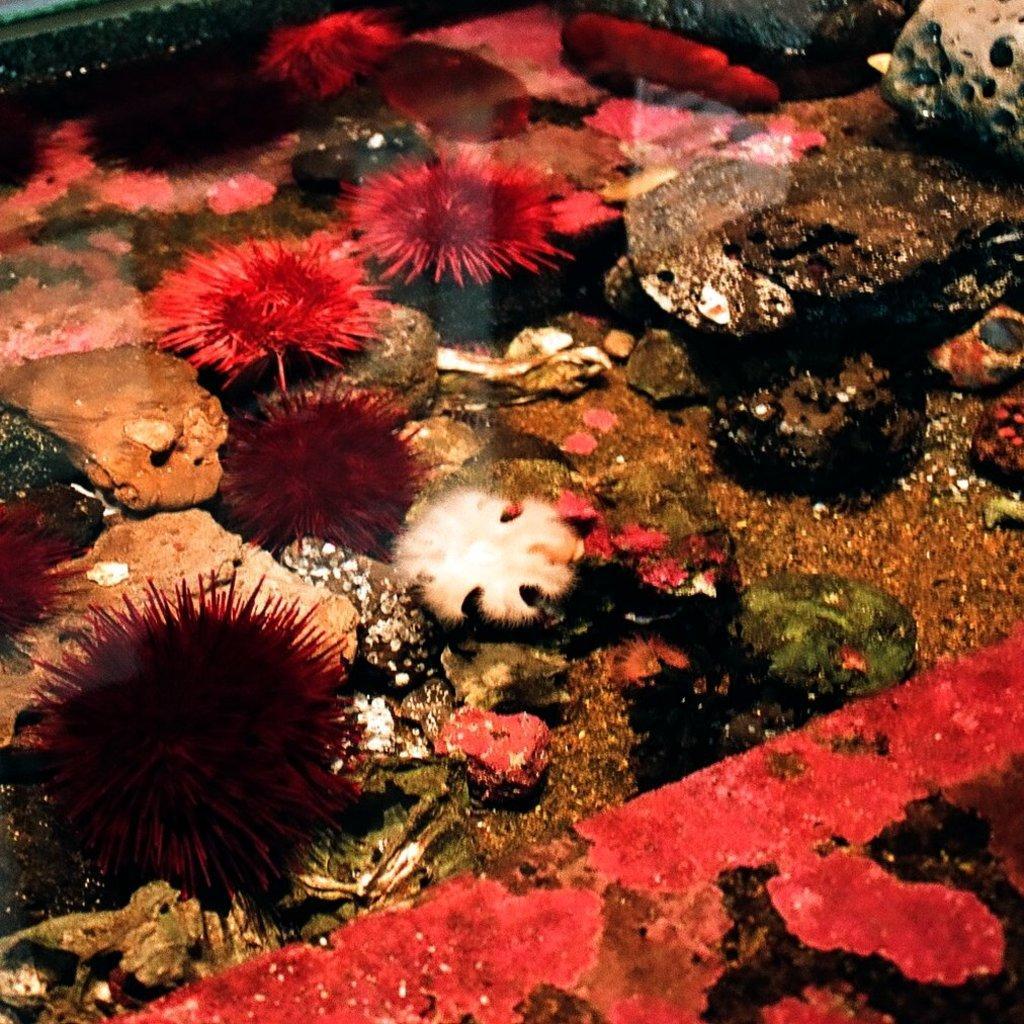In one or two sentences, can you explain what this image depicts? In this picture we can see inside view of the sea water. In the front we can see some coral rocks and pink color flowers. 